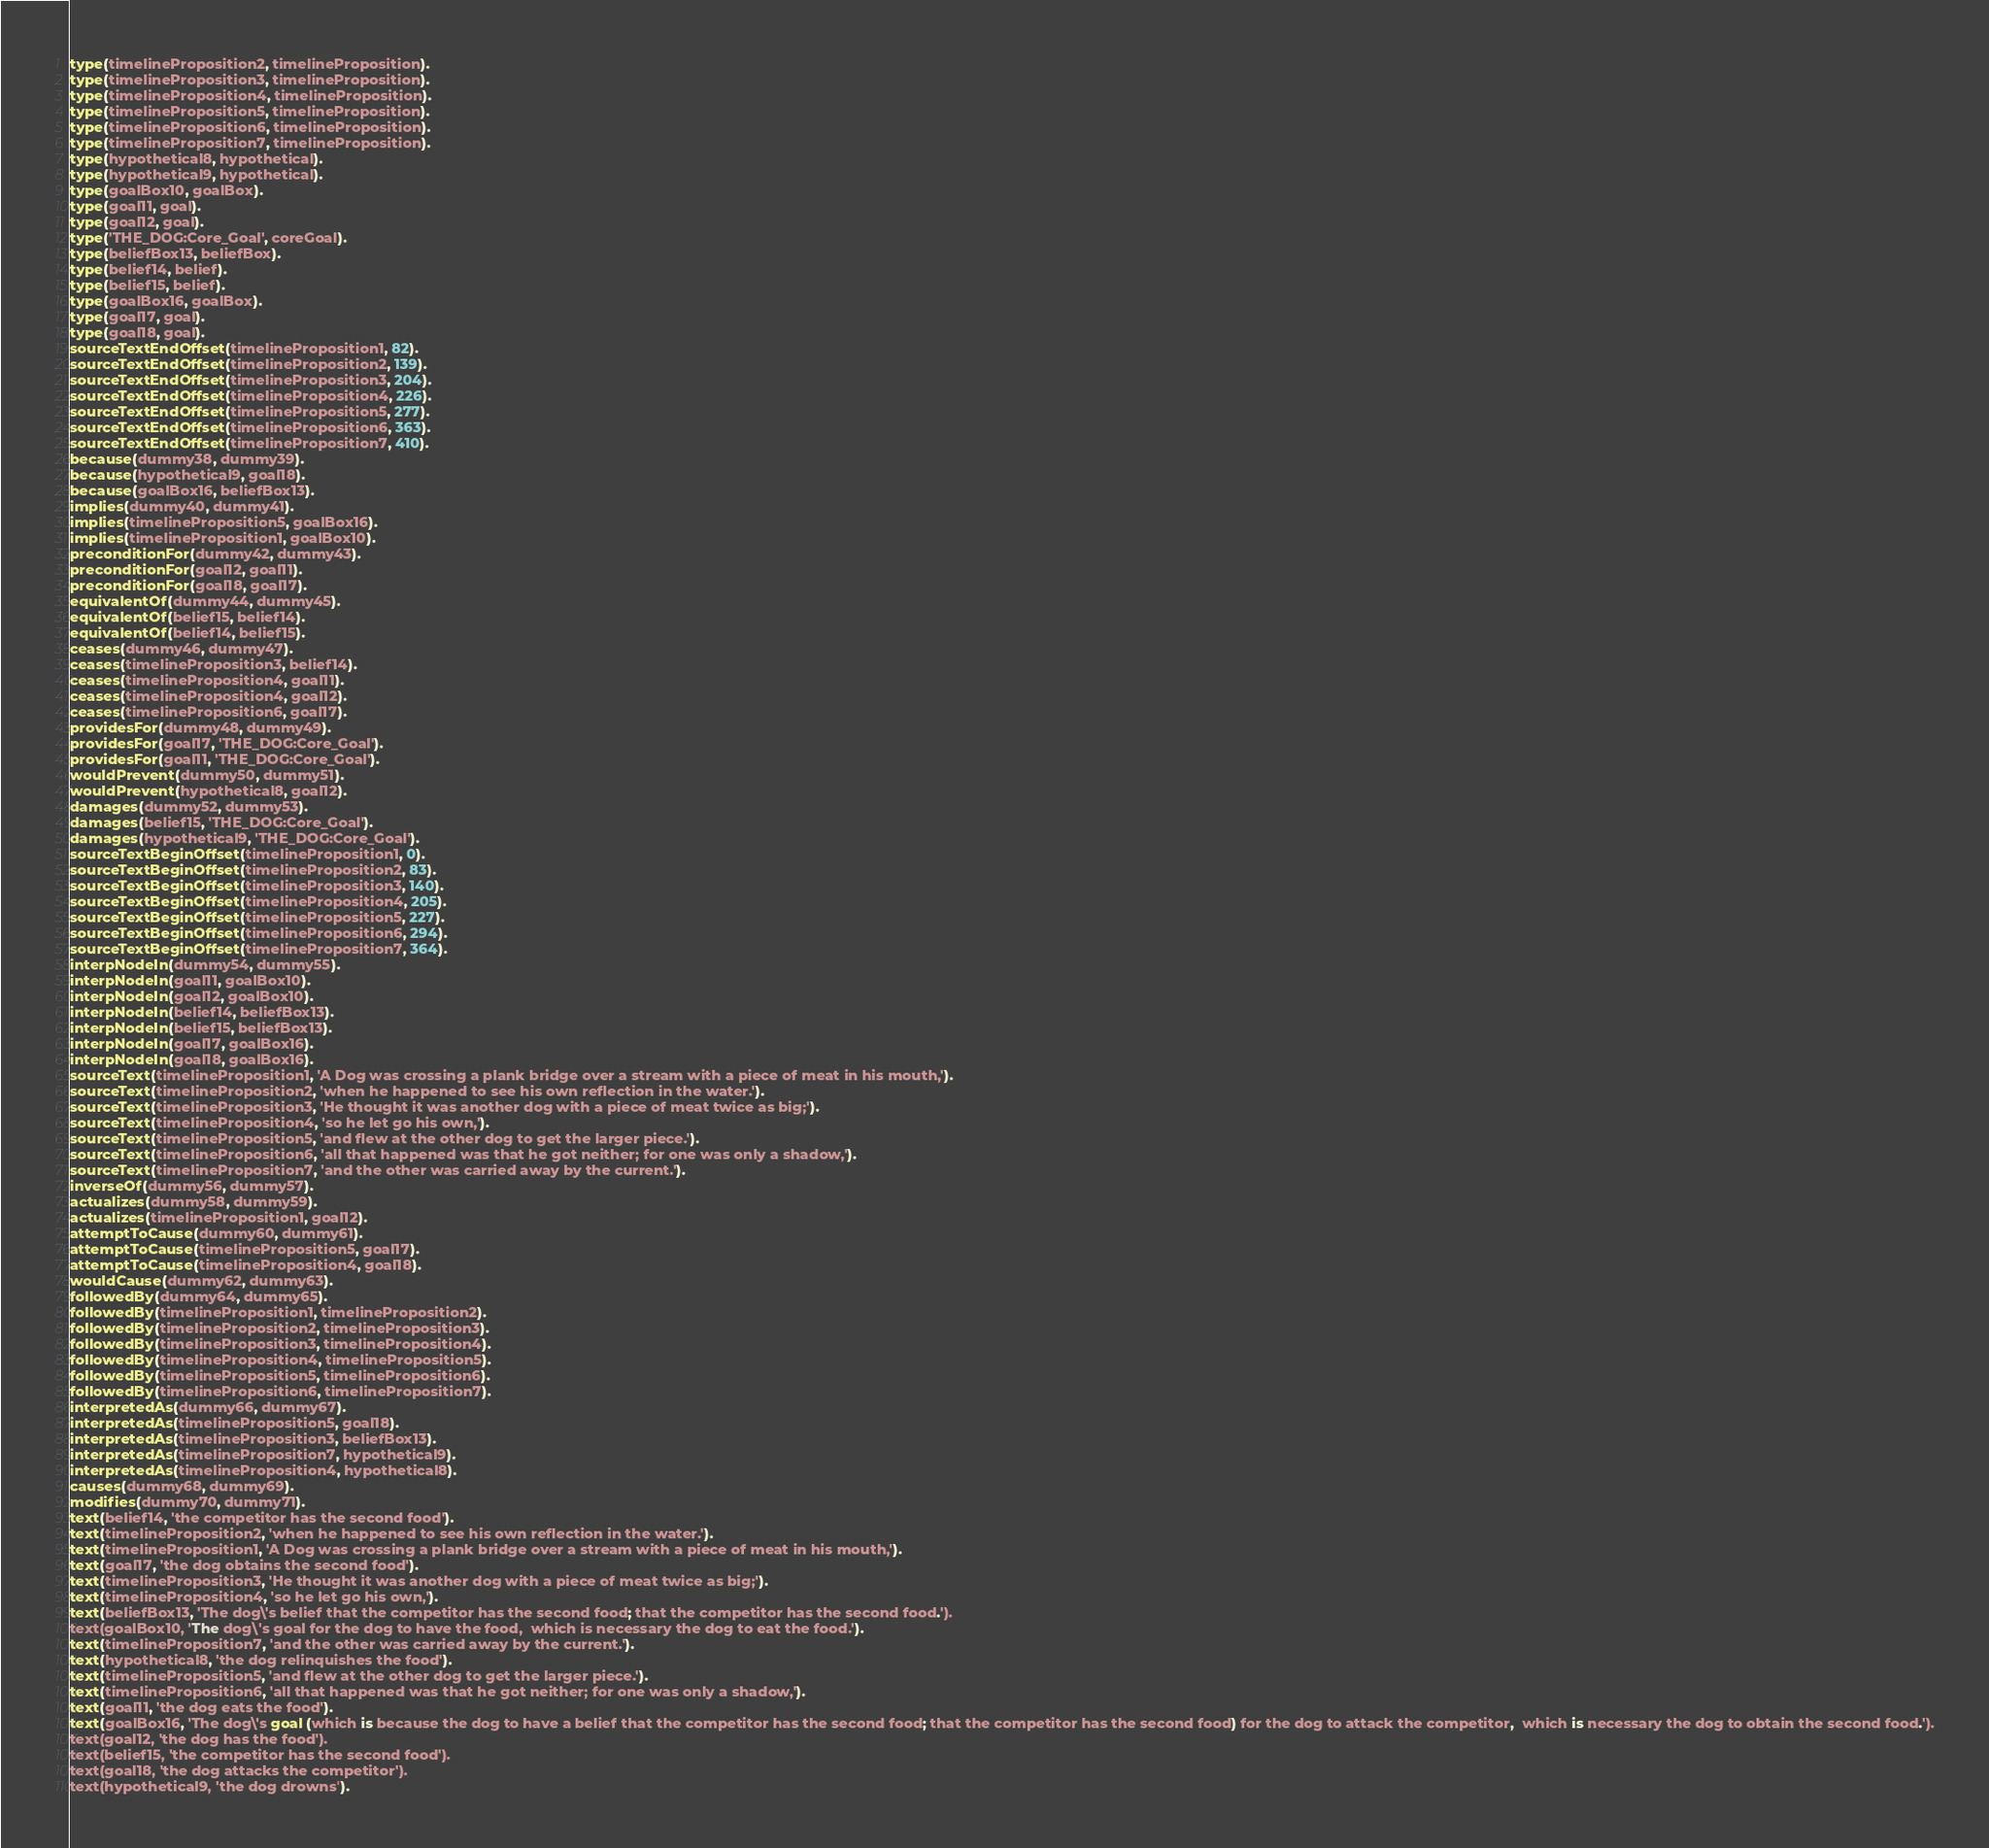<code> <loc_0><loc_0><loc_500><loc_500><_Prolog_>type(timelineProposition2, timelineProposition).
type(timelineProposition3, timelineProposition).
type(timelineProposition4, timelineProposition).
type(timelineProposition5, timelineProposition).
type(timelineProposition6, timelineProposition).
type(timelineProposition7, timelineProposition).
type(hypothetical8, hypothetical).
type(hypothetical9, hypothetical).
type(goalBox10, goalBox).
type(goal11, goal).
type(goal12, goal).
type('THE_DOG:Core_Goal', coreGoal).
type(beliefBox13, beliefBox).
type(belief14, belief).
type(belief15, belief).
type(goalBox16, goalBox).
type(goal17, goal).
type(goal18, goal).
sourceTextEndOffset(timelineProposition1, 82).
sourceTextEndOffset(timelineProposition2, 139).
sourceTextEndOffset(timelineProposition3, 204).
sourceTextEndOffset(timelineProposition4, 226).
sourceTextEndOffset(timelineProposition5, 277).
sourceTextEndOffset(timelineProposition6, 363).
sourceTextEndOffset(timelineProposition7, 410).
because(dummy38, dummy39).
because(hypothetical9, goal18).
because(goalBox16, beliefBox13).
implies(dummy40, dummy41).
implies(timelineProposition5, goalBox16).
implies(timelineProposition1, goalBox10).
preconditionFor(dummy42, dummy43).
preconditionFor(goal12, goal11).
preconditionFor(goal18, goal17).
equivalentOf(dummy44, dummy45).
equivalentOf(belief15, belief14).
equivalentOf(belief14, belief15).
ceases(dummy46, dummy47).
ceases(timelineProposition3, belief14).
ceases(timelineProposition4, goal11).
ceases(timelineProposition4, goal12).
ceases(timelineProposition6, goal17).
providesFor(dummy48, dummy49).
providesFor(goal17, 'THE_DOG:Core_Goal').
providesFor(goal11, 'THE_DOG:Core_Goal').
wouldPrevent(dummy50, dummy51).
wouldPrevent(hypothetical8, goal12).
damages(dummy52, dummy53).
damages(belief15, 'THE_DOG:Core_Goal').
damages(hypothetical9, 'THE_DOG:Core_Goal').
sourceTextBeginOffset(timelineProposition1, 0).
sourceTextBeginOffset(timelineProposition2, 83).
sourceTextBeginOffset(timelineProposition3, 140).
sourceTextBeginOffset(timelineProposition4, 205).
sourceTextBeginOffset(timelineProposition5, 227).
sourceTextBeginOffset(timelineProposition6, 294).
sourceTextBeginOffset(timelineProposition7, 364).
interpNodeIn(dummy54, dummy55).
interpNodeIn(goal11, goalBox10).
interpNodeIn(goal12, goalBox10).
interpNodeIn(belief14, beliefBox13).
interpNodeIn(belief15, beliefBox13).
interpNodeIn(goal17, goalBox16).
interpNodeIn(goal18, goalBox16).
sourceText(timelineProposition1, 'A Dog was crossing a plank bridge over a stream with a piece of meat in his mouth,').
sourceText(timelineProposition2, 'when he happened to see his own reflection in the water.').
sourceText(timelineProposition3, 'He thought it was another dog with a piece of meat twice as big;').
sourceText(timelineProposition4, 'so he let go his own,').
sourceText(timelineProposition5, 'and flew at the other dog to get the larger piece.').
sourceText(timelineProposition6, 'all that happened was that he got neither; for one was only a shadow,').
sourceText(timelineProposition7, 'and the other was carried away by the current.').
inverseOf(dummy56, dummy57).
actualizes(dummy58, dummy59).
actualizes(timelineProposition1, goal12).
attemptToCause(dummy60, dummy61).
attemptToCause(timelineProposition5, goal17).
attemptToCause(timelineProposition4, goal18).
wouldCause(dummy62, dummy63).
followedBy(dummy64, dummy65).
followedBy(timelineProposition1, timelineProposition2).
followedBy(timelineProposition2, timelineProposition3).
followedBy(timelineProposition3, timelineProposition4).
followedBy(timelineProposition4, timelineProposition5).
followedBy(timelineProposition5, timelineProposition6).
followedBy(timelineProposition6, timelineProposition7).
interpretedAs(dummy66, dummy67).
interpretedAs(timelineProposition5, goal18).
interpretedAs(timelineProposition3, beliefBox13).
interpretedAs(timelineProposition7, hypothetical9).
interpretedAs(timelineProposition4, hypothetical8).
causes(dummy68, dummy69).
modifies(dummy70, dummy71).
text(belief14, 'the competitor has the second food').
text(timelineProposition2, 'when he happened to see his own reflection in the water.').
text(timelineProposition1, 'A Dog was crossing a plank bridge over a stream with a piece of meat in his mouth,').
text(goal17, 'the dog obtains the second food').
text(timelineProposition3, 'He thought it was another dog with a piece of meat twice as big;').
text(timelineProposition4, 'so he let go his own,').
text(beliefBox13, 'The dog\'s belief that the competitor has the second food; that the competitor has the second food.').
text(goalBox10, 'The dog\'s goal for the dog to have the food,  which is necessary the dog to eat the food.').
text(timelineProposition7, 'and the other was carried away by the current.').
text(hypothetical8, 'the dog relinquishes the food').
text(timelineProposition5, 'and flew at the other dog to get the larger piece.').
text(timelineProposition6, 'all that happened was that he got neither; for one was only a shadow,').
text(goal11, 'the dog eats the food').
text(goalBox16, 'The dog\'s goal (which is because the dog to have a belief that the competitor has the second food; that the competitor has the second food) for the dog to attack the competitor,  which is necessary the dog to obtain the second food.').
text(goal12, 'the dog has the food').
text(belief15, 'the competitor has the second food').
text(goal18, 'the dog attacks the competitor').
text(hypothetical9, 'the dog drowns').

</code> 